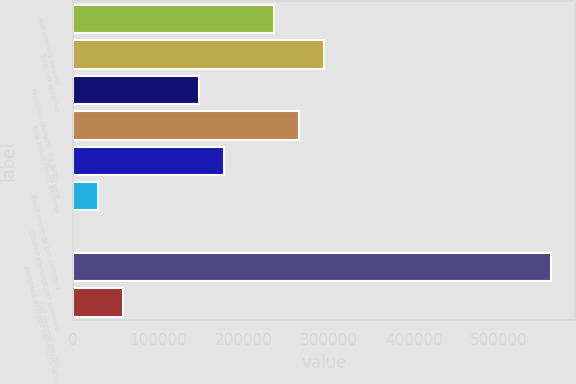Convert chart. <chart><loc_0><loc_0><loc_500><loc_500><bar_chart><fcel>Net interest income<fcel>Total net revenue<fcel>Provision (benefit) for loan<fcel>Total non-interest expense<fcel>Net income<fcel>Basic earnings per common<fcel>Diluted earnings per common<fcel>Weighted average common shares<fcel>Net interest margin<nl><fcel>236009<fcel>295011<fcel>147506<fcel>265510<fcel>177007<fcel>29501.9<fcel>0.91<fcel>560520<fcel>59002.9<nl></chart> 